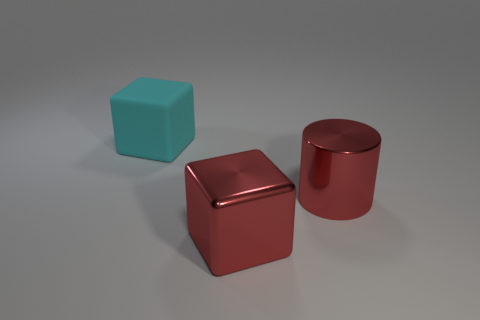Add 3 red metallic cylinders. How many objects exist? 6 Subtract all cyan cubes. How many cubes are left? 1 Subtract 1 cyan blocks. How many objects are left? 2 Subtract all cylinders. How many objects are left? 2 Subtract 2 blocks. How many blocks are left? 0 Subtract all yellow cubes. Subtract all gray cylinders. How many cubes are left? 2 Subtract all red cylinders. Subtract all cyan blocks. How many objects are left? 1 Add 2 big cubes. How many big cubes are left? 4 Add 1 large shiny cylinders. How many large shiny cylinders exist? 2 